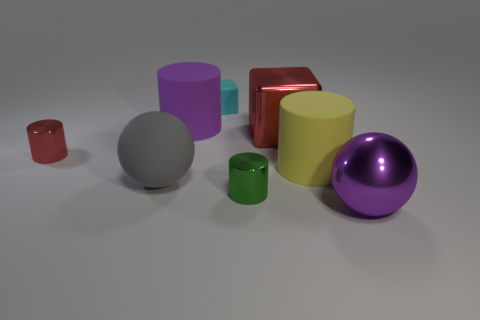Add 1 green rubber cylinders. How many objects exist? 9 Subtract all gray balls. How many balls are left? 1 Subtract all small red cylinders. How many cylinders are left? 3 Subtract all cubes. How many objects are left? 6 Subtract 2 balls. How many balls are left? 0 Subtract all red blocks. Subtract all green cylinders. How many blocks are left? 1 Subtract all green balls. How many green blocks are left? 0 Subtract all small cylinders. Subtract all yellow cylinders. How many objects are left? 5 Add 8 large red cubes. How many large red cubes are left? 9 Add 7 big matte cylinders. How many big matte cylinders exist? 9 